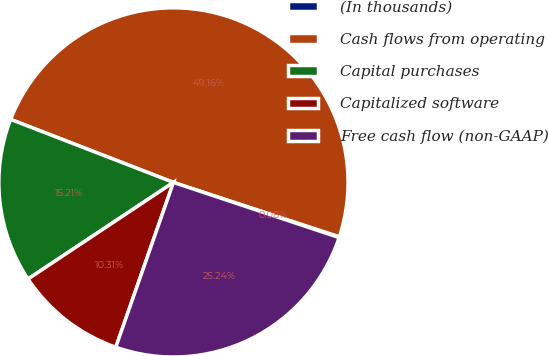Convert chart to OTSL. <chart><loc_0><loc_0><loc_500><loc_500><pie_chart><fcel>(In thousands)<fcel>Cash flows from operating<fcel>Capital purchases<fcel>Capitalized software<fcel>Free cash flow (non-GAAP)<nl><fcel>0.08%<fcel>49.16%<fcel>15.21%<fcel>10.31%<fcel>25.24%<nl></chart> 